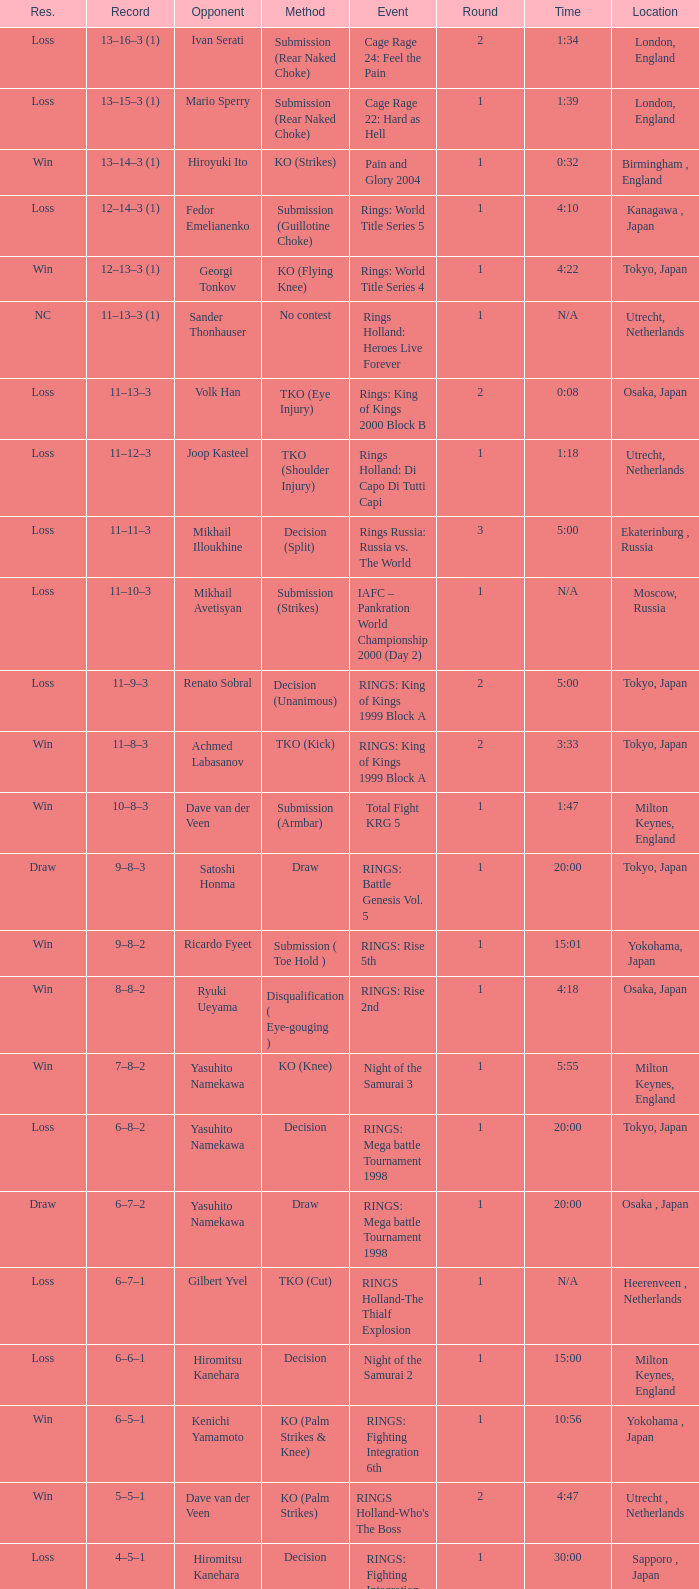Can you parse all the data within this table? {'header': ['Res.', 'Record', 'Opponent', 'Method', 'Event', 'Round', 'Time', 'Location'], 'rows': [['Loss', '13–16–3 (1)', 'Ivan Serati', 'Submission (Rear Naked Choke)', 'Cage Rage 24: Feel the Pain', '2', '1:34', 'London, England'], ['Loss', '13–15–3 (1)', 'Mario Sperry', 'Submission (Rear Naked Choke)', 'Cage Rage 22: Hard as Hell', '1', '1:39', 'London, England'], ['Win', '13–14–3 (1)', 'Hiroyuki Ito', 'KO (Strikes)', 'Pain and Glory 2004', '1', '0:32', 'Birmingham , England'], ['Loss', '12–14–3 (1)', 'Fedor Emelianenko', 'Submission (Guillotine Choke)', 'Rings: World Title Series 5', '1', '4:10', 'Kanagawa , Japan'], ['Win', '12–13–3 (1)', 'Georgi Tonkov', 'KO (Flying Knee)', 'Rings: World Title Series 4', '1', '4:22', 'Tokyo, Japan'], ['NC', '11–13–3 (1)', 'Sander Thonhauser', 'No contest', 'Rings Holland: Heroes Live Forever', '1', 'N/A', 'Utrecht, Netherlands'], ['Loss', '11–13–3', 'Volk Han', 'TKO (Eye Injury)', 'Rings: King of Kings 2000 Block B', '2', '0:08', 'Osaka, Japan'], ['Loss', '11–12–3', 'Joop Kasteel', 'TKO (Shoulder Injury)', 'Rings Holland: Di Capo Di Tutti Capi', '1', '1:18', 'Utrecht, Netherlands'], ['Loss', '11–11–3', 'Mikhail Illoukhine', 'Decision (Split)', 'Rings Russia: Russia vs. The World', '3', '5:00', 'Ekaterinburg , Russia'], ['Loss', '11–10–3', 'Mikhail Avetisyan', 'Submission (Strikes)', 'IAFC – Pankration World Championship 2000 (Day 2)', '1', 'N/A', 'Moscow, Russia'], ['Loss', '11–9–3', 'Renato Sobral', 'Decision (Unanimous)', 'RINGS: King of Kings 1999 Block A', '2', '5:00', 'Tokyo, Japan'], ['Win', '11–8–3', 'Achmed Labasanov', 'TKO (Kick)', 'RINGS: King of Kings 1999 Block A', '2', '3:33', 'Tokyo, Japan'], ['Win', '10–8–3', 'Dave van der Veen', 'Submission (Armbar)', 'Total Fight KRG 5', '1', '1:47', 'Milton Keynes, England'], ['Draw', '9–8–3', 'Satoshi Honma', 'Draw', 'RINGS: Battle Genesis Vol. 5', '1', '20:00', 'Tokyo, Japan'], ['Win', '9–8–2', 'Ricardo Fyeet', 'Submission ( Toe Hold )', 'RINGS: Rise 5th', '1', '15:01', 'Yokohama, Japan'], ['Win', '8–8–2', 'Ryuki Ueyama', 'Disqualification ( Eye-gouging )', 'RINGS: Rise 2nd', '1', '4:18', 'Osaka, Japan'], ['Win', '7–8–2', 'Yasuhito Namekawa', 'KO (Knee)', 'Night of the Samurai 3', '1', '5:55', 'Milton Keynes, England'], ['Loss', '6–8–2', 'Yasuhito Namekawa', 'Decision', 'RINGS: Mega battle Tournament 1998', '1', '20:00', 'Tokyo, Japan'], ['Draw', '6–7–2', 'Yasuhito Namekawa', 'Draw', 'RINGS: Mega battle Tournament 1998', '1', '20:00', 'Osaka , Japan'], ['Loss', '6–7–1', 'Gilbert Yvel', 'TKO (Cut)', 'RINGS Holland-The Thialf Explosion', '1', 'N/A', 'Heerenveen , Netherlands'], ['Loss', '6–6–1', 'Hiromitsu Kanehara', 'Decision', 'Night of the Samurai 2', '1', '15:00', 'Milton Keynes, England'], ['Win', '6–5–1', 'Kenichi Yamamoto', 'KO (Palm Strikes & Knee)', 'RINGS: Fighting Integration 6th', '1', '10:56', 'Yokohama , Japan'], ['Win', '5–5–1', 'Dave van der Veen', 'KO (Palm Strikes)', "RINGS Holland-Who's The Boss", '2', '4:47', 'Utrecht , Netherlands'], ['Loss', '4–5–1', 'Hiromitsu Kanehara', 'Decision', 'RINGS: Fighting Integration 3rd', '1', '30:00', 'Sapporo , Japan'], ['Win', '4–4–1', 'Sander Thonhauser', 'Submission ( Armbar )', 'Night of the Samurai 1', '1', '0:55', 'Milton Keynes, England'], ['Loss', '3–4–1', 'Joop Kasteel', 'Submission ( Headlock )', 'RINGS: Mega Battle Tournament 1997', '1', '8:55', 'Tokyo, Japan'], ['Win', '3–3–1', 'Peter Dijkman', 'Submission ( Rear Naked Choke )', 'Total Fight Night', '1', '4:46', 'Milton Keynes, England'], ['Loss', '2–3–1', 'Masayuki Naruse', 'Submission ( Shoulder Necklock )', 'RINGS: Fighting Extension Vol. 4', '1', '12:58', 'Tokyo, Japan'], ['Win', '2–2–1', 'Sean McCully', 'Submission (Guillotine Choke)', 'RINGS: Battle Genesis Vol. 1', '1', '3:59', 'Tokyo, Japan'], ['Loss', '1–2–1', 'Hans Nijman', 'Submission ( Guillotine Choke )', 'RINGS Holland-The Final Challenge', '2', '0:51', 'Amsterdam, Netherlands'], ['Loss', '1–1–1', 'Cees Bezems', 'TKO (Cut)', 'IMA – Battle of Styles', '1', 'N/A', 'Amsterdam, Netherlands'], ['Draw', '1–0–1', 'Andre Mannaart', 'Draw', 'RINGS Holland-Kings of Martial Arts', '2', '5:00', 'Amsterdam , Netherlands'], ['Win', '1–0–0', 'Boston Jones', 'TKO (Cut)', 'Fighting Arts Gala', '2', '2:30', 'Milton Keynes , England']]} Who was the rival in london, england in a round less than 2? Mario Sperry. 